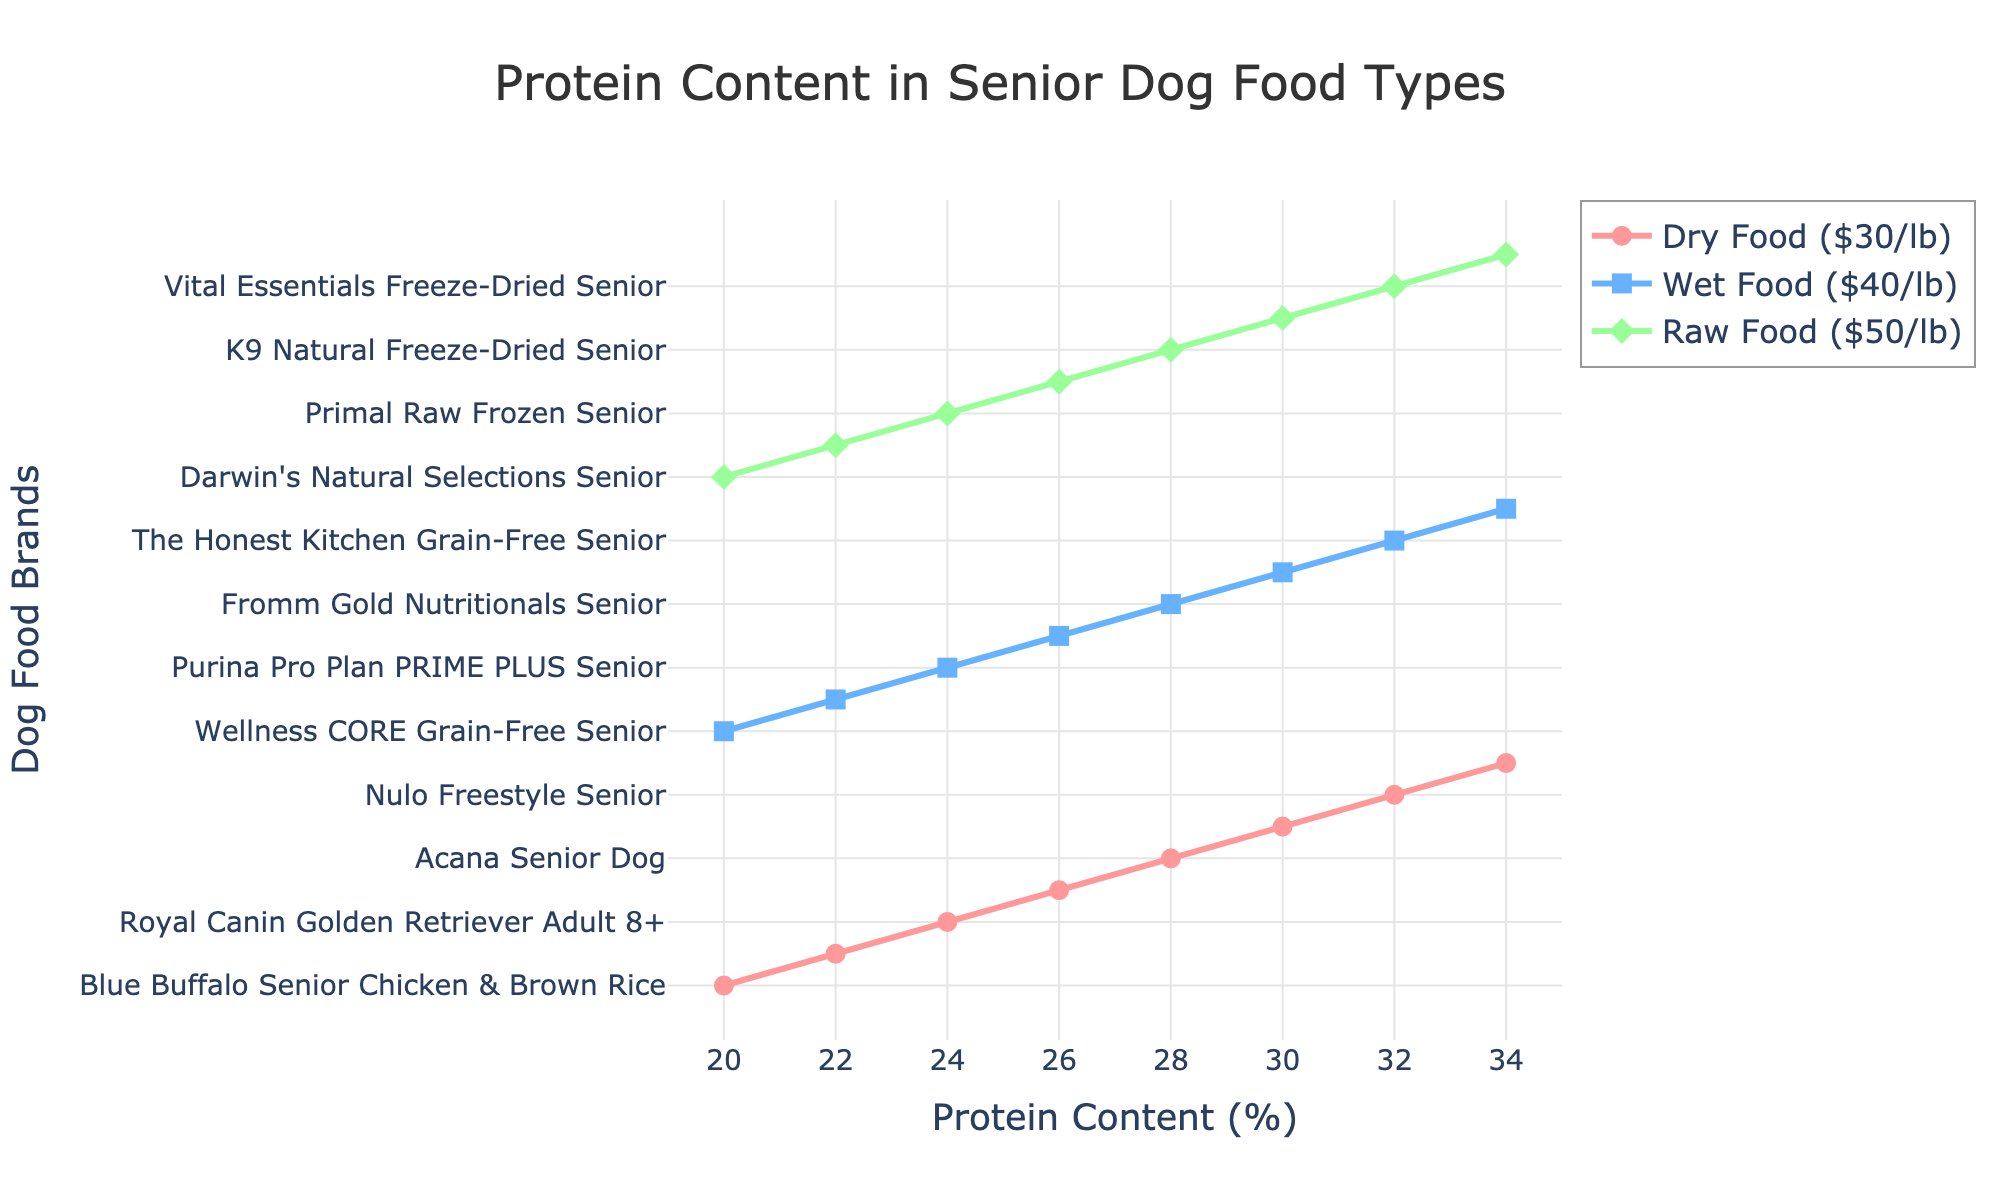What's the protein content range of the dog food brands in the visualization? The figure shows protein content ranging from 20% to 34% for various dog food brands.
Answer: 20% to 34% Which type of dog food has the highest protein content at the highest price point? Looking at the highest protein content at 34%, the dog food type colored green (representing raw food) points to "Bravo Balance Senior".
Answer: Raw Food ($50/lb) Which type of dog food shows the most consistent increase in protein content with increasing protein levels? Observing the trend lines, the dry food type (red) shows a more consistent incremental pattern compared to wet (blue) and raw (green) food types.
Answer: Dry Food ($30/lb) How does the protein content of "Nulo Freestyle Senior" compare with that of "Ziwi Peak Tripe & Lamb Senior"? "Nulo Freestyle Senior" (dry food) has a protein content of 32%, while "Ziwi Peak Tripe & Lamb Senior" (wet food) also shows up at the same protein content level of 32%. This indicates they are equal in protein content.
Answer: Equal What is the protein content of "Royal Canin Golden Retriever Adult 8+"? "Royal Canin Golden Retriever Adult 8+" is marked under dry food (red line) with a protein content of 24%.
Answer: 24% Which food type has the lowest maximum protein content value? By comparing the peaks visually, dry food's maximum protein content is 34%, wet food also 34%, and raw food reaches the same, so no type has a distinctly lower maximum value when purely looking at the peaks.
Answer: None Does wet food show a higher protein content overall compared to dry food? Comparing the height peaks of the blue (wet food) and red (dry food) lines, the highest points of both types are the same at 34%. Wet food does not show an overall higher protein content.
Answer: No At 26% protein content, which wet food brand is displayed? Following the blue line (wet food) directly at the 26% protein level, it points to "Instinct Original Grain-Free Senior".
Answer: Instinct Original Grain-Free Senior If considering dog foods with at least 30% protein content, which brands and types would be suitable? Checking the figure, at protein contents of 30% and above, the suitable brands would be "Taste of the Wild Pacific Stream Senior" (dry), "Ziwi Peak Tripe & Lamb Senior" (wet), "Stella & Chewy's Senior Blend" (raw), "Nulo Freestyle Senior" (dry), "The Honest Kitchen Grain-Free Senior" (wet), "Vital Essentials Freeze-Dried Senior" (raw), "Victor Senior Healthy Weight" (dry), "Weruva Paw Lickin' Chicken Senior" (wet), and "Bravo Balance Senior" (raw).
Answer: Nine brands across all types 